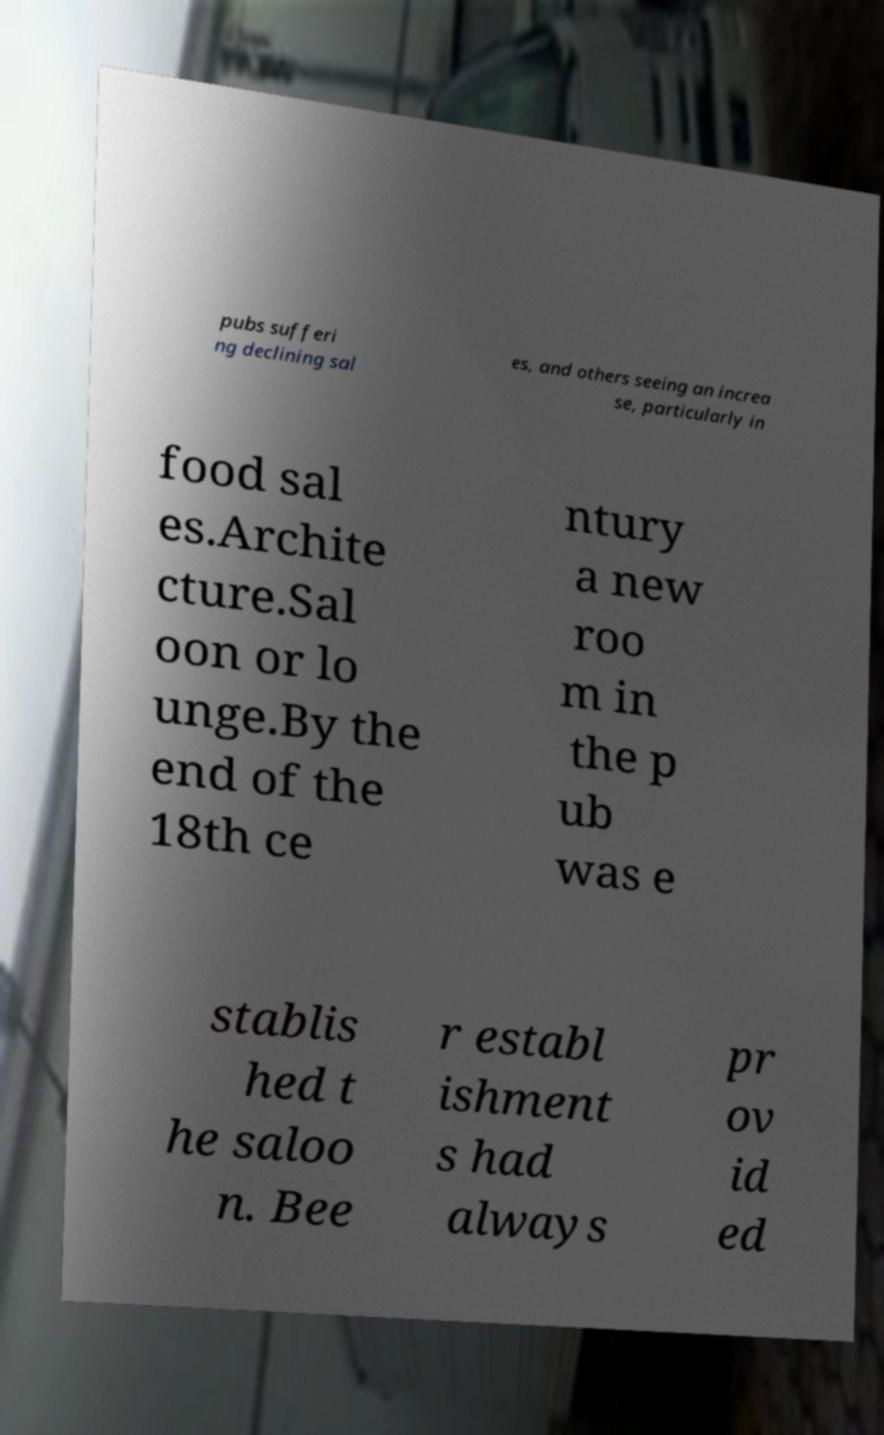There's text embedded in this image that I need extracted. Can you transcribe it verbatim? pubs sufferi ng declining sal es, and others seeing an increa se, particularly in food sal es.Archite cture.Sal oon or lo unge.By the end of the 18th ce ntury a new roo m in the p ub was e stablis hed t he saloo n. Bee r establ ishment s had always pr ov id ed 